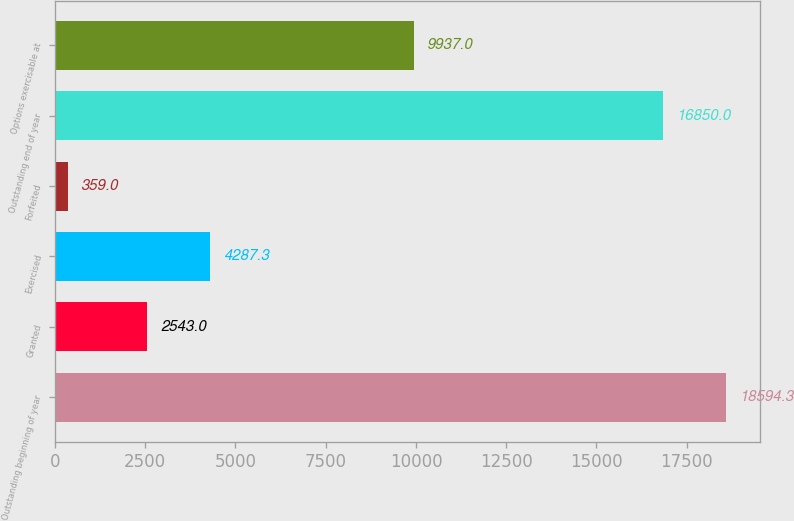Convert chart to OTSL. <chart><loc_0><loc_0><loc_500><loc_500><bar_chart><fcel>Outstanding beginning of year<fcel>Granted<fcel>Exercised<fcel>Forfeited<fcel>Outstanding end of year<fcel>Options exercisable at<nl><fcel>18594.3<fcel>2543<fcel>4287.3<fcel>359<fcel>16850<fcel>9937<nl></chart> 